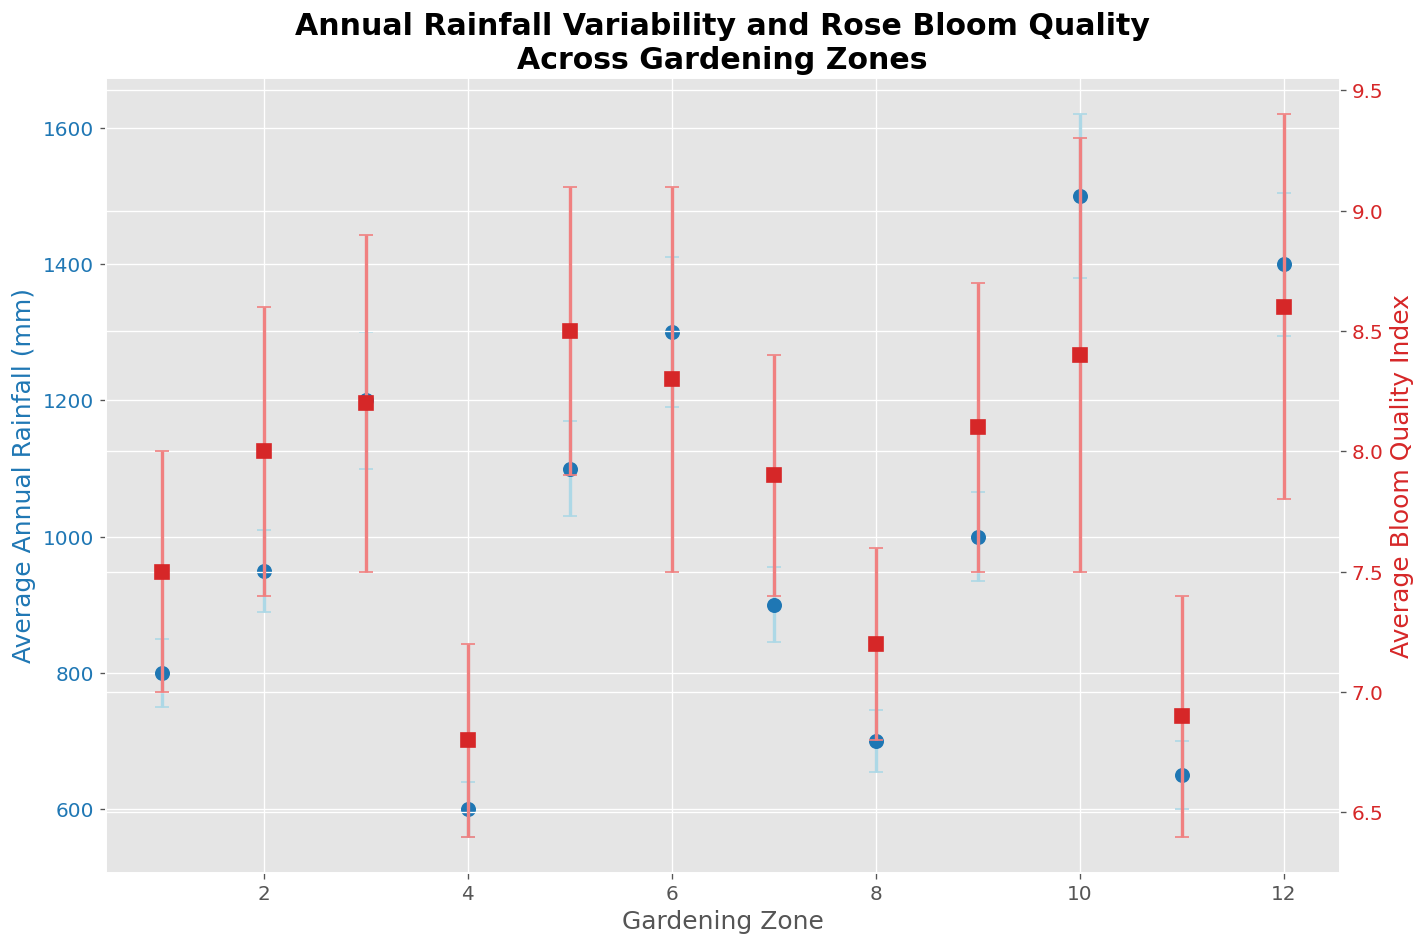What's the relationship between average annual rainfall and average bloom quality index in gardening zone 5? In gardening zone 5, the average annual rainfall is 1100 mm with an average bloom quality index of 8.5. We look at the error bars to understand variability but for the central value, there's a clear relationship between high rainfall and high bloom quality in this zone.
Answer: Higher rainfall, higher bloom quality Which gardening zone has the highest variability in bloom quality? To determine the highest variability, we compare the error bars of bloom quality indices for all zones. Zone 10 has the largest error bar, indicating the highest variability.
Answer: Zone 10 How does the bloom quality change from zone 1 to zone 2? The average bloom quality index increases from 7.5 in zone 1 to 8.0 in zone 2.
Answer: It increases In which zone do high average annual rainfall and bloom quality coincide together? Zones 6, 10, and 12 have high average annual rainfall (1300 mm, 1500 mm, and 1400 mm respectively) and high bloom quality indices (8.3, 8.4, and 8.6 respectively).
Answer: Zones 6, 10, 12 Is there a gardening zone where both the average rainfall and bloom quality are below average? Zones 4, 8, and 11 have both below-average rainfall and bloom quality.
Answer: Zones 4, 8, 11 Compare the average rainfall variability of zone 3 to that of zone 7. Zone 3 has a standard deviation of 100 mm, and zone 7 has a standard deviation of 55 mm. Therefore, zone 3 has higher rainfall variability.
Answer: Zone 3 has higher variability Which zone has the smallest error bars for bloom quality? By visually comparing the error bars of the bloom quality indices, zone 4 has the smallest error bars, indicating the least variability.
Answer: Zone 4 What is the trend of bloom quality as annual rainfall increases from zones 1 to 12? Generally, as the annual rainfall increases from zones 1 to 12, the bloom quality index also tends to increase, with some fluctuations.
Answer: Increase trend with fluctuations In which zone does the average bloom quality exceed the average bloom quality of zone 7 by at least 0.5 units? Zone 7 has an average bloom quality of 7.9. Zones 3, 5, 6, 9, 10, and 12 have bloom quality indices exceeding 8.4, which is 0.5 units higher than 7.9.
Answer: Zones 3, 5, 6, 9, 10, 12 What is the difference in average annual rainfall between the zones with the highest and lowest values? The zones with the highest and lowest average annual rainfall are zone 10 (1500 mm) and zone 4 (600 mm), respectively. The difference is 1500 - 600 = 900 mm.
Answer: 900 mm 